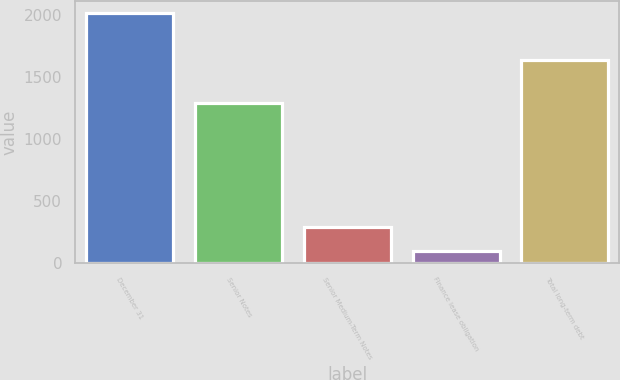Convert chart to OTSL. <chart><loc_0><loc_0><loc_500><loc_500><bar_chart><fcel>December 31<fcel>Senior Notes<fcel>Senior Medium-Term Notes<fcel>Finance lease obligation<fcel>Total long-term debt<nl><fcel>2012<fcel>1288<fcel>286.7<fcel>95<fcel>1632<nl></chart> 